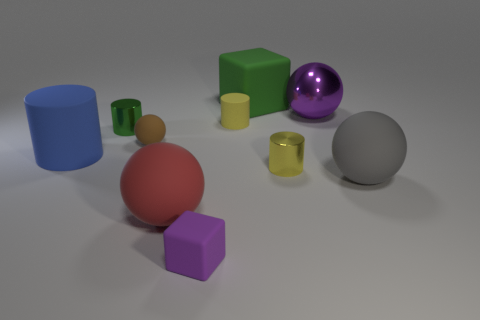There is another tiny cylinder that is the same color as the tiny rubber cylinder; what is it made of?
Your answer should be very brief. Metal. How many things are either big rubber blocks or large things behind the big red matte object?
Your answer should be compact. 4. What number of other objects are the same color as the metal ball?
Provide a succinct answer. 1. There is a red object; is its size the same as the purple object to the right of the tiny block?
Make the answer very short. Yes. There is a metallic object that is on the left side of the yellow metal object; does it have the same size as the tiny purple rubber block?
Your answer should be compact. Yes. How many other things are there of the same material as the red ball?
Provide a succinct answer. 6. Is the number of tiny green things that are right of the tiny block the same as the number of large green blocks behind the large rubber block?
Make the answer very short. Yes. What color is the block in front of the rubber cylinder on the left side of the small block that is left of the big gray ball?
Offer a terse response. Purple. What shape is the small rubber thing that is to the right of the small purple cube?
Provide a succinct answer. Cylinder. There is a small brown thing that is made of the same material as the big cylinder; what shape is it?
Ensure brevity in your answer.  Sphere. 